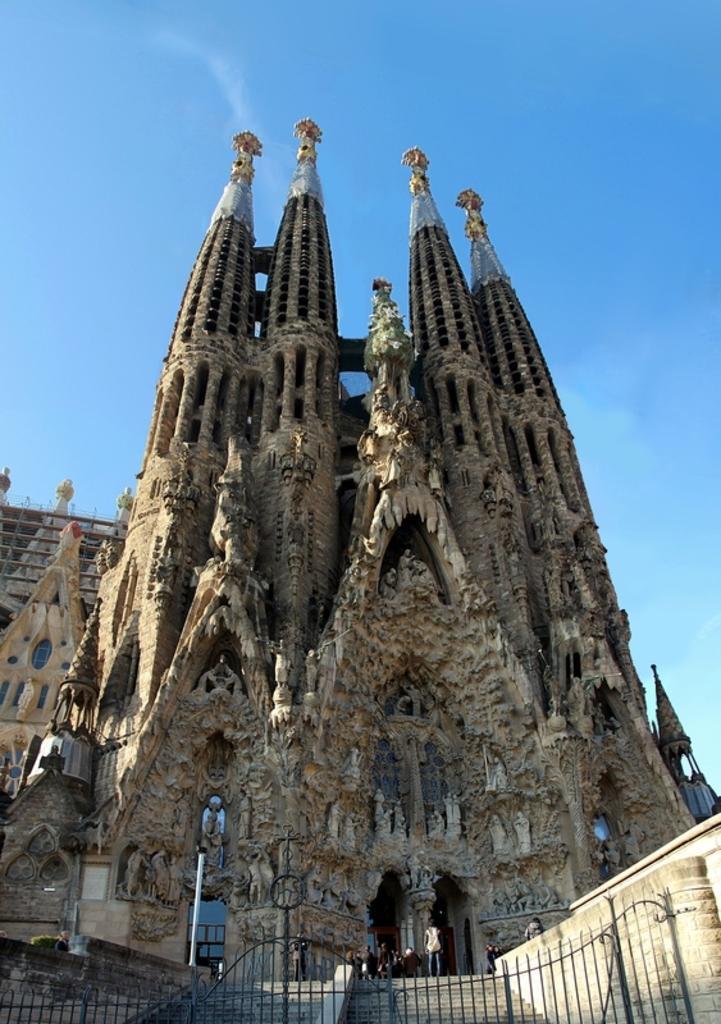Please provide a concise description of this image. In this image I can see the metal gate and the stairs. In the background I can see few people, building and the sky. 